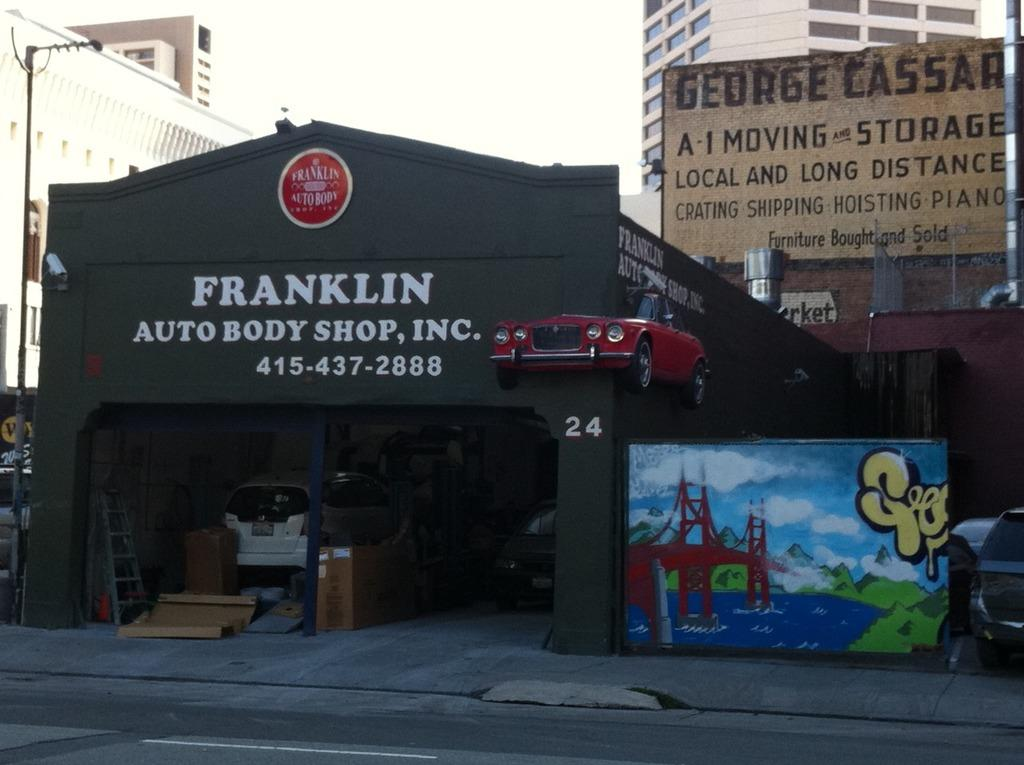Provide a one-sentence caption for the provided image. A body shop called Franklin Auto Body Shop. 